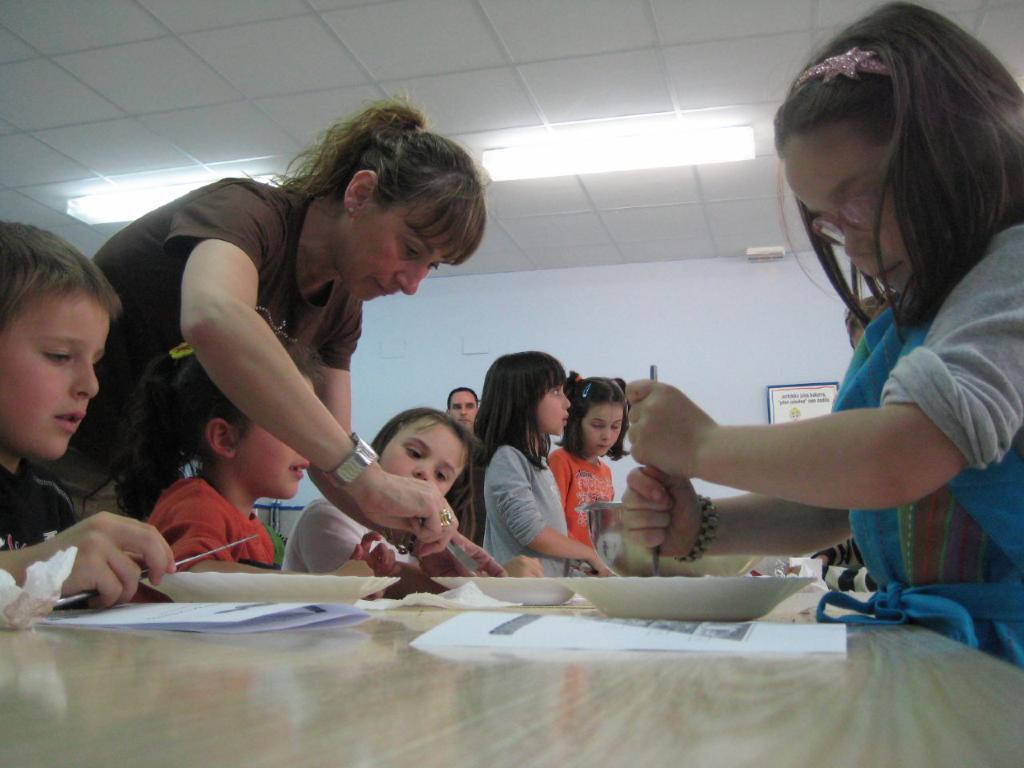Could you give a brief overview of what you see in this image? In this image we can see some people standing. In that the woman and a child are holding the knives. We can also see a group of people sitting beside a table containing some plates and papers on it. On the backside we can see a board on a wall and a roof with some ceiling lights. 